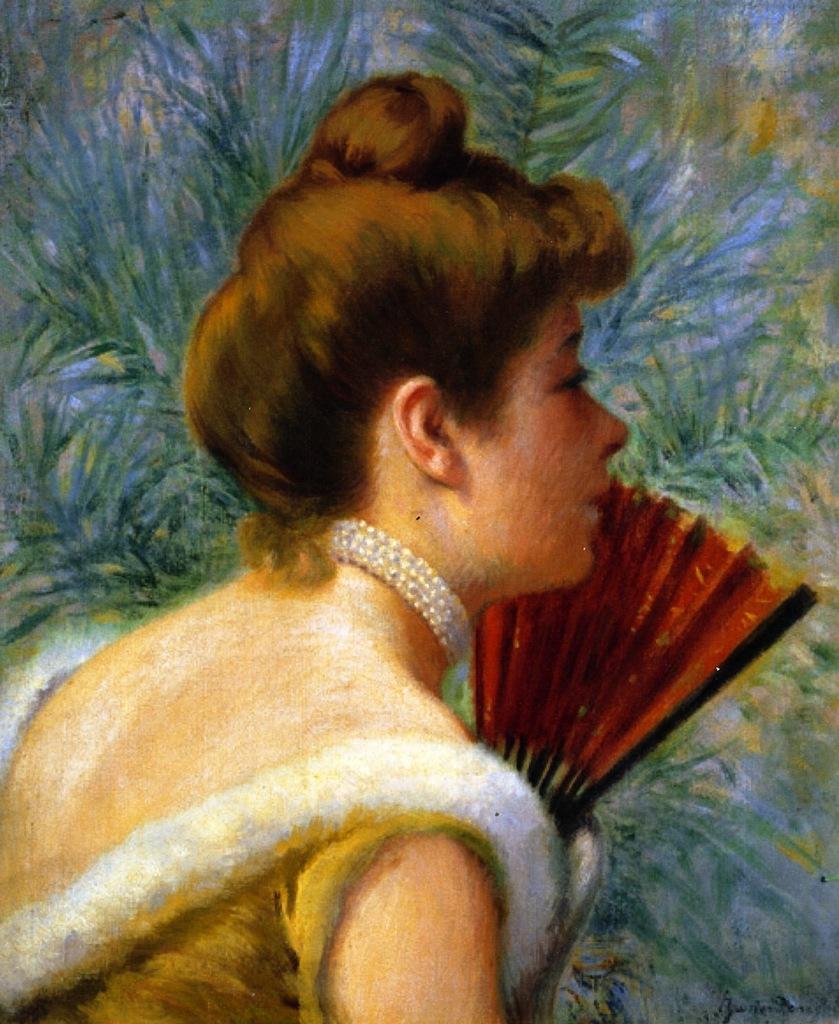Could you give a brief overview of what you see in this image? This is a painting. There is a painting of a woman holding the object. At the back it looks like a plant. 